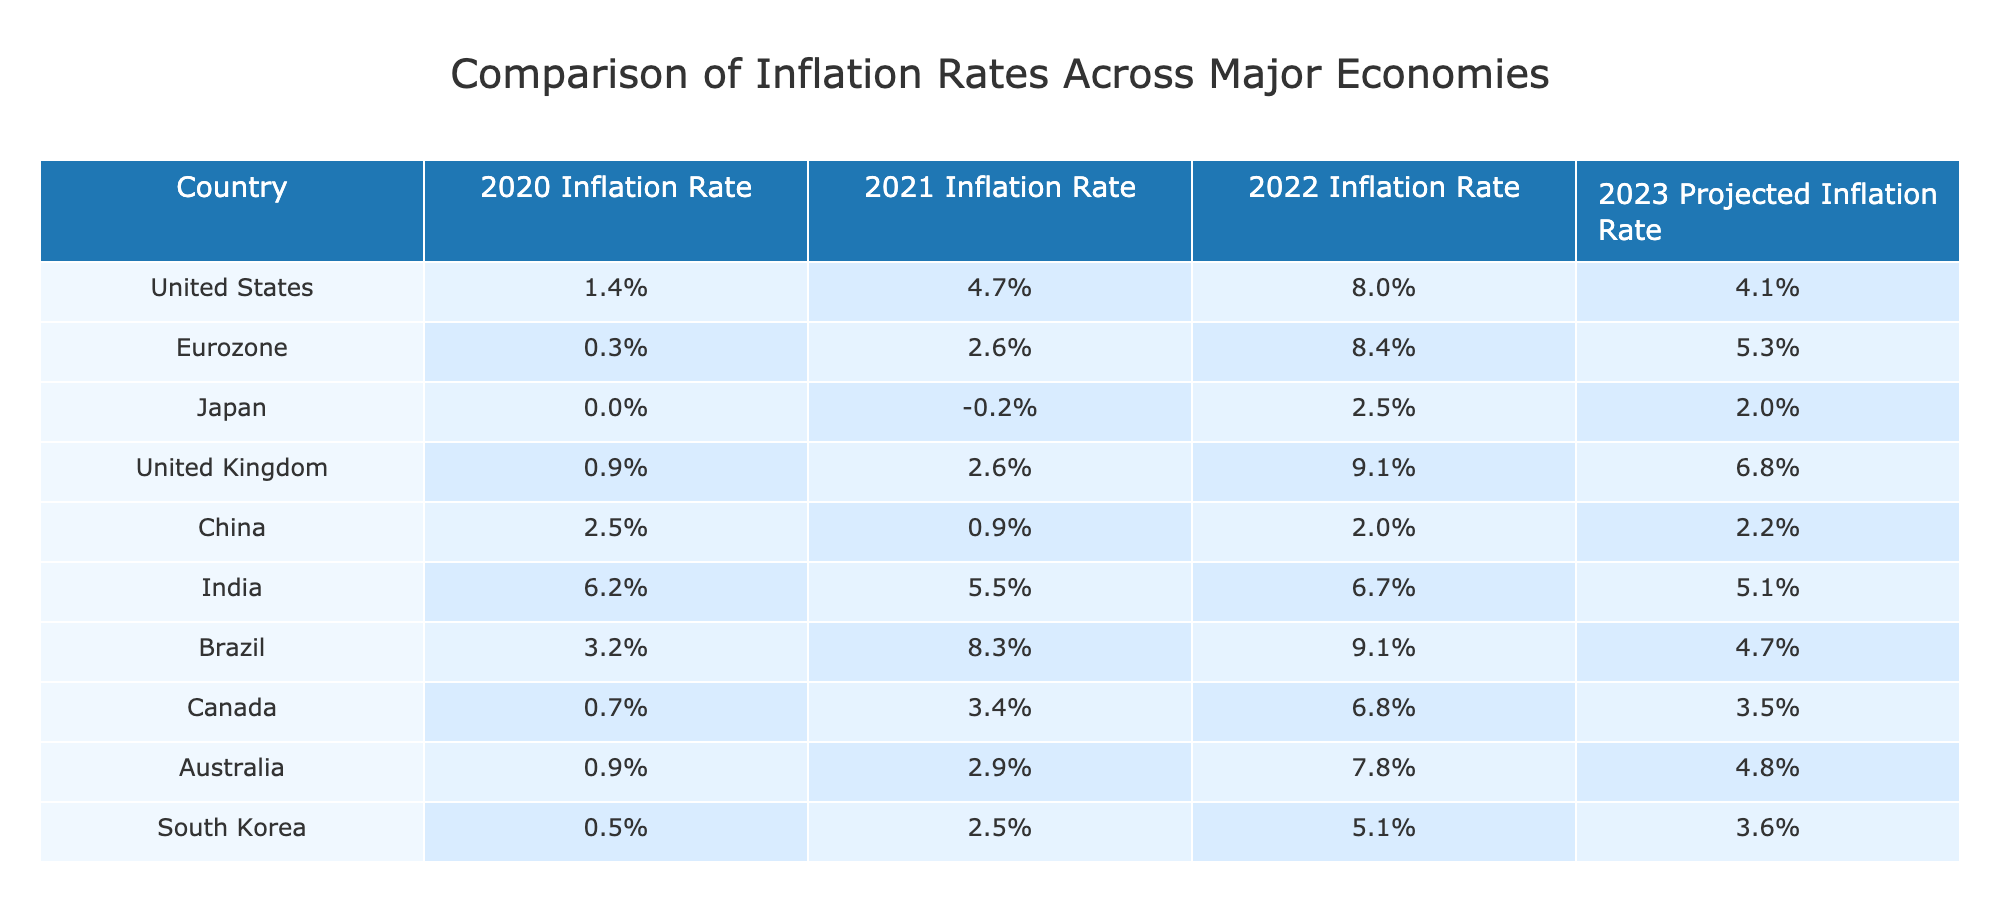What was the inflation rate in the United Kingdom in 2022? The table states that the inflation rate for the United Kingdom in 2022 is 9.1%. This value can be found directly in the respective row and column of the table.
Answer: 9.1% Which country had the highest projected inflation rate for 2023? Looking at the projected inflation rates for 2023, the United Kingdom has the highest rate at 6.8%. This is determined by comparing the last column for all countries.
Answer: 6.8% What is the difference in inflation rates between Brazil and Canada in 2021? The inflation rate for Brazil in 2021 is 8.3% and for Canada, it is 3.4%. The difference is calculated as 8.3% - 3.4% = 4.9%.
Answer: 4.9% Is it true that Japan's inflation rate decreased from 2021 to 2022? The table shows that Japan's inflation rate was -0.2% in 2021 and rose to 2.5% in 2022. Since it increased, the statement is false.
Answer: No What was the average inflation rate for China over the years 2020 to 2023? The respective inflation rates for China are 2.5%, 0.9%, 2.0%, and 2.2%. Adding these, we get 2.5 + 0.9 + 2.0 + 2.2 = 7.6%. To find the average, we divide by 4, resulting in 7.6% / 4 = 1.9%.
Answer: 1.9% Which countries had inflation rates above 5% in 2022? The table lists the inflation rates in 2022: the United States (8.0%), Eurozone (8.4%), United Kingdom (9.1%), and Brazil (9.1%). All these countries have rates above 5%, which can be confirmed by checking their respective inflation rates in 2022.
Answer: United States, Eurozone, United Kingdom, Brazil What was the difference between the highest and lowest inflation rate in the Eurozone in the years listed? The highest inflation rate in the Eurozone occurred in 2022 at 8.4%, while the lowest was 0.3% in 2020. Therefore, the difference is 8.4% - 0.3% = 8.1%.
Answer: 8.1% Did any country experience a negative inflation rate in 2021? According to the table, Japan had a negative inflation rate of -0.2% in 2021. Therefore, the statement is true.
Answer: Yes 